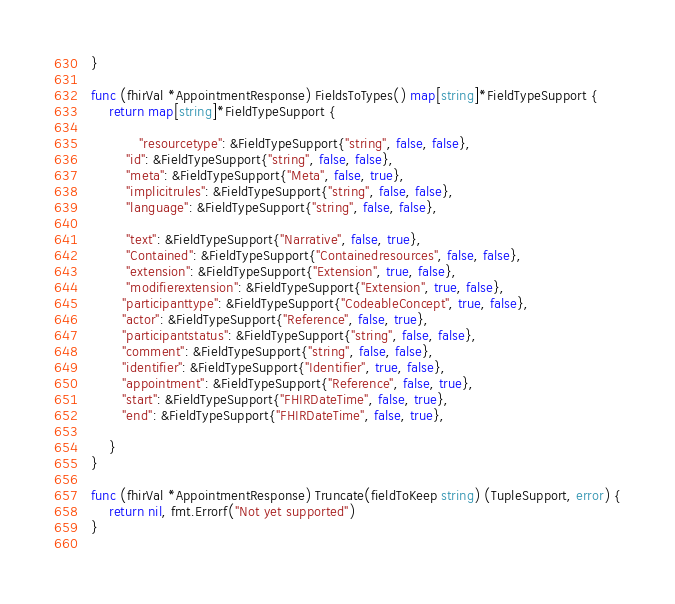Convert code to text. <code><loc_0><loc_0><loc_500><loc_500><_Go_> }
 
 func (fhirVal *AppointmentResponse) FieldsToTypes() map[string]*FieldTypeSupport {
	 return map[string]*FieldTypeSupport {
 
	 		"resourcetype": &FieldTypeSupport{"string", false, false},
		 "id": &FieldTypeSupport{"string", false, false},
		 "meta": &FieldTypeSupport{"Meta", false, true},
		 "implicitrules": &FieldTypeSupport{"string", false, false},
		 "language": &FieldTypeSupport{"string", false, false},
 
		 "text": &FieldTypeSupport{"Narrative", false, true},
		 "Contained": &FieldTypeSupport{"Containedresources", false, false},
		 "extension": &FieldTypeSupport{"Extension", true, false},
		 "modifierextension": &FieldTypeSupport{"Extension", true, false},						
 		"participanttype": &FieldTypeSupport{"CodeableConcept", true, false},
 		"actor": &FieldTypeSupport{"Reference", false, true},
 		"participantstatus": &FieldTypeSupport{"string", false, false},
 		"comment": &FieldTypeSupport{"string", false, false},
 		"identifier": &FieldTypeSupport{"Identifier", true, false},
 		"appointment": &FieldTypeSupport{"Reference", false, true},
 		"start": &FieldTypeSupport{"FHIRDateTime", false, true},
 		"end": &FieldTypeSupport{"FHIRDateTime", false, true},
 
	 }
 }
 
 func (fhirVal *AppointmentResponse) Truncate(fieldToKeep string) (TupleSupport, error) {
	 return nil, fmt.Errorf("Not yet supported")
 }
 </code> 